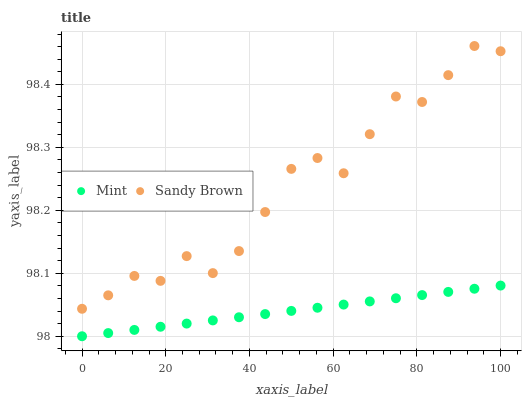Does Mint have the minimum area under the curve?
Answer yes or no. Yes. Does Sandy Brown have the maximum area under the curve?
Answer yes or no. Yes. Does Mint have the maximum area under the curve?
Answer yes or no. No. Is Mint the smoothest?
Answer yes or no. Yes. Is Sandy Brown the roughest?
Answer yes or no. Yes. Is Mint the roughest?
Answer yes or no. No. Does Mint have the lowest value?
Answer yes or no. Yes. Does Sandy Brown have the highest value?
Answer yes or no. Yes. Does Mint have the highest value?
Answer yes or no. No. Is Mint less than Sandy Brown?
Answer yes or no. Yes. Is Sandy Brown greater than Mint?
Answer yes or no. Yes. Does Mint intersect Sandy Brown?
Answer yes or no. No. 